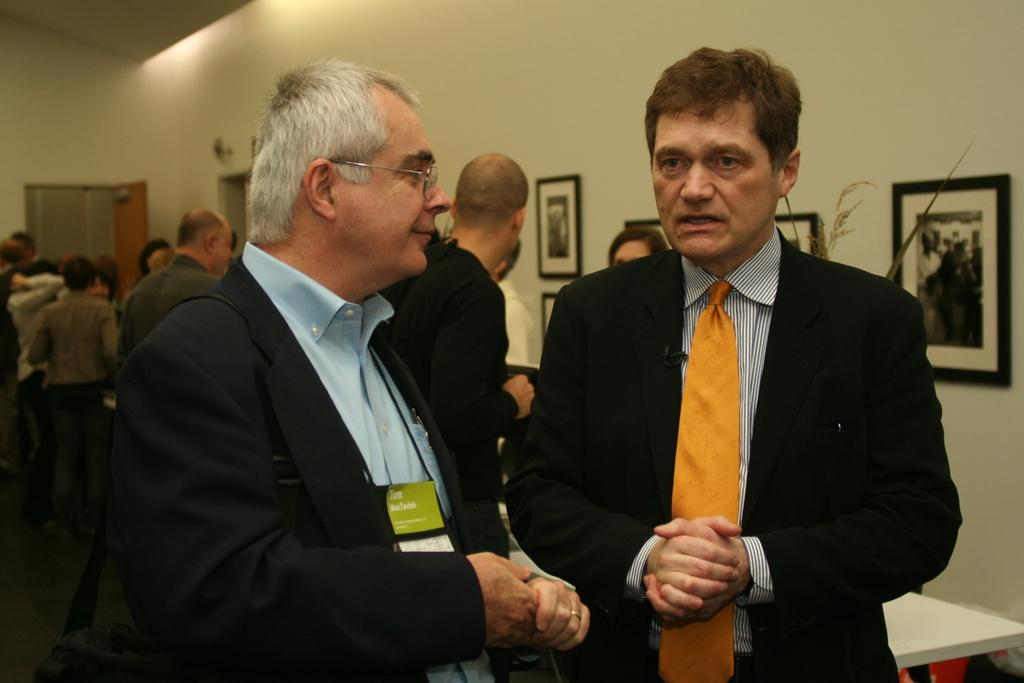How many people are in the image? There is a group of persons standing in the image. What can be seen in the background of the image? There is a wall in the background of the image. What is on the wall in the image? There are photo frames on the wall. What type of produce is being harvested by the grandmother in the image? There is no grandmother or produce present in the image. What type of destruction can be seen in the image? There is no destruction present in the image; it features a group of persons standing in front of a wall with photo frames. 